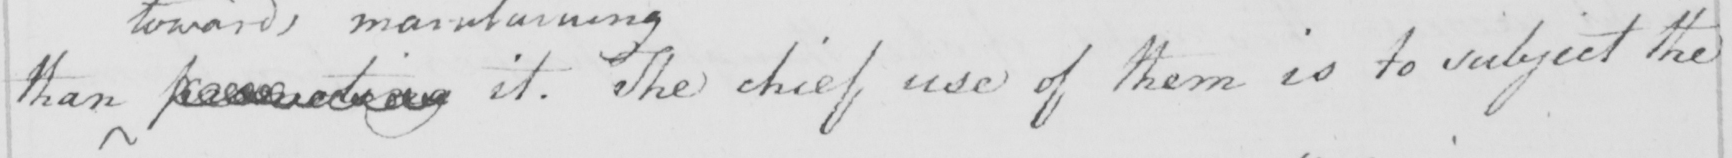What does this handwritten line say? than   <gap/>   it . The chief use of them is to subject the 